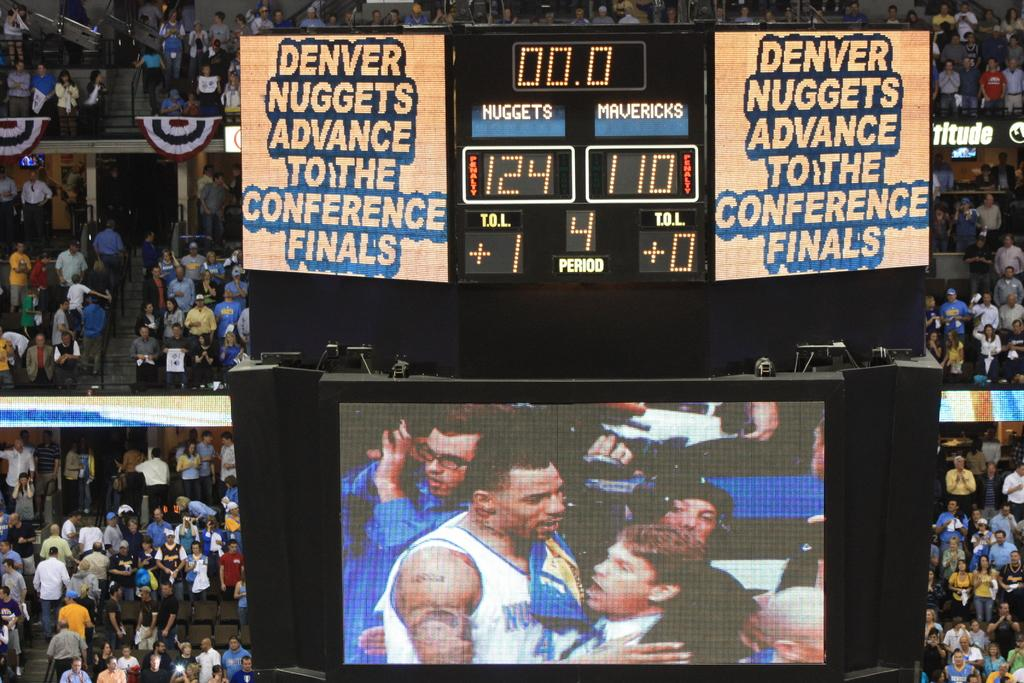<image>
Render a clear and concise summary of the photo. A jumbotron at a Nuggets game saying they advance. 